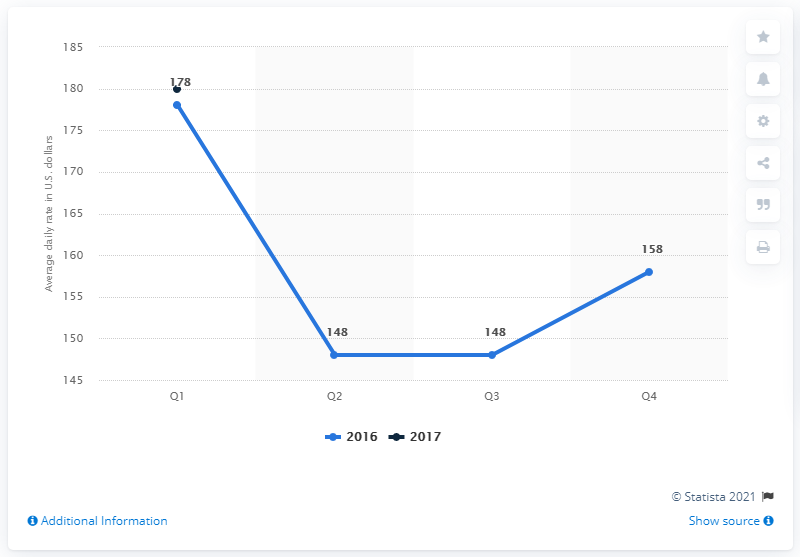Mention a couple of crucial points in this snapshot. According to data from the first quarter of 2017, the average daily rate of hotels in Las Vegas, Nevada, in the United States was approximately $180. The average daily rate of hotels was the same in both the second and third quarters of 2016. In 2016, the average daily rate was 158. 